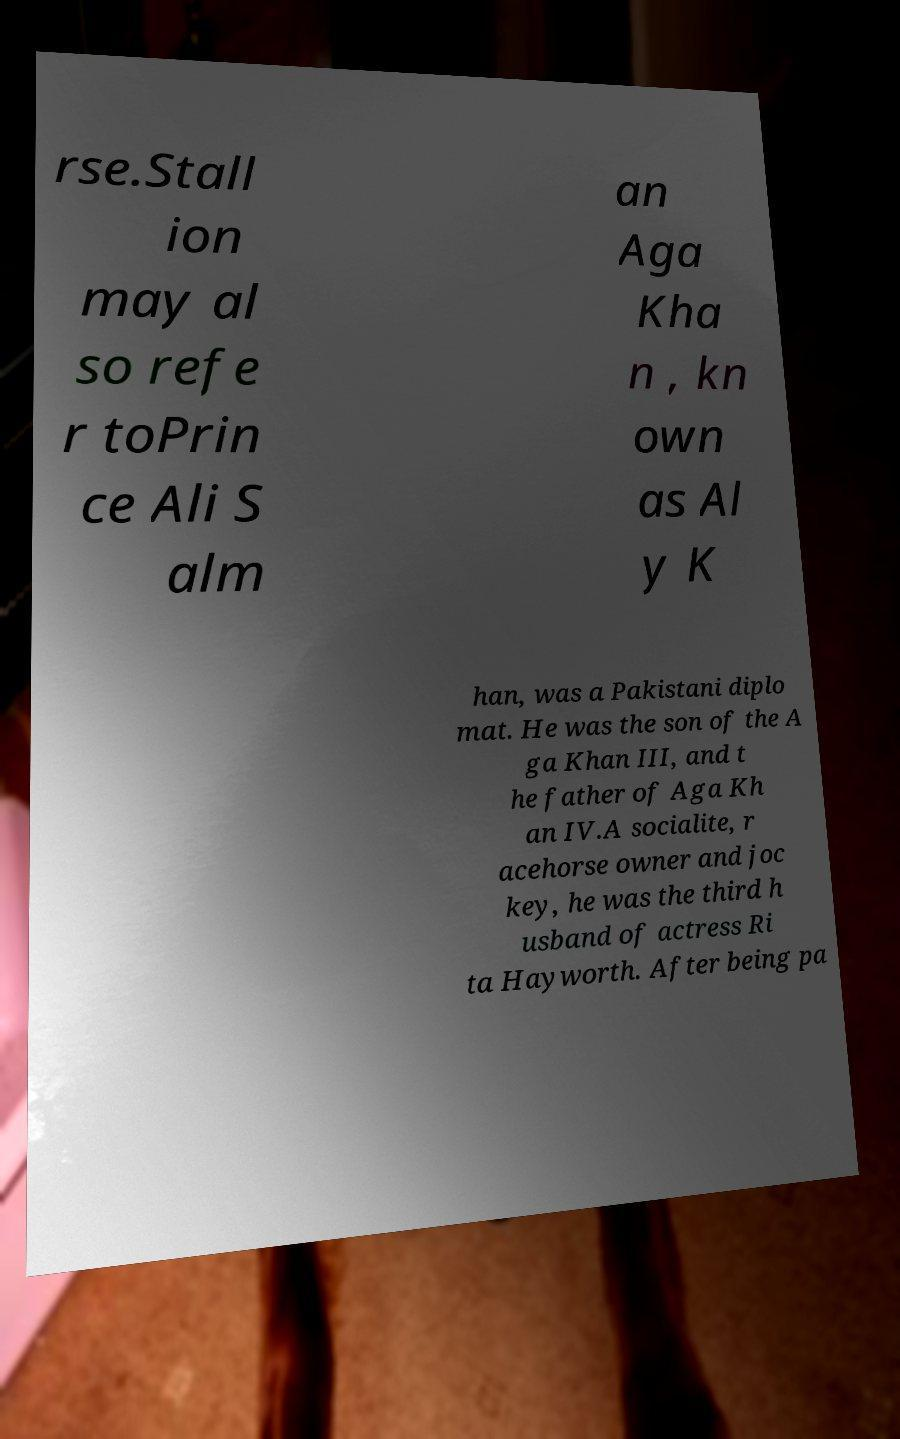Could you assist in decoding the text presented in this image and type it out clearly? rse.Stall ion may al so refe r toPrin ce Ali S alm an Aga Kha n , kn own as Al y K han, was a Pakistani diplo mat. He was the son of the A ga Khan III, and t he father of Aga Kh an IV.A socialite, r acehorse owner and joc key, he was the third h usband of actress Ri ta Hayworth. After being pa 